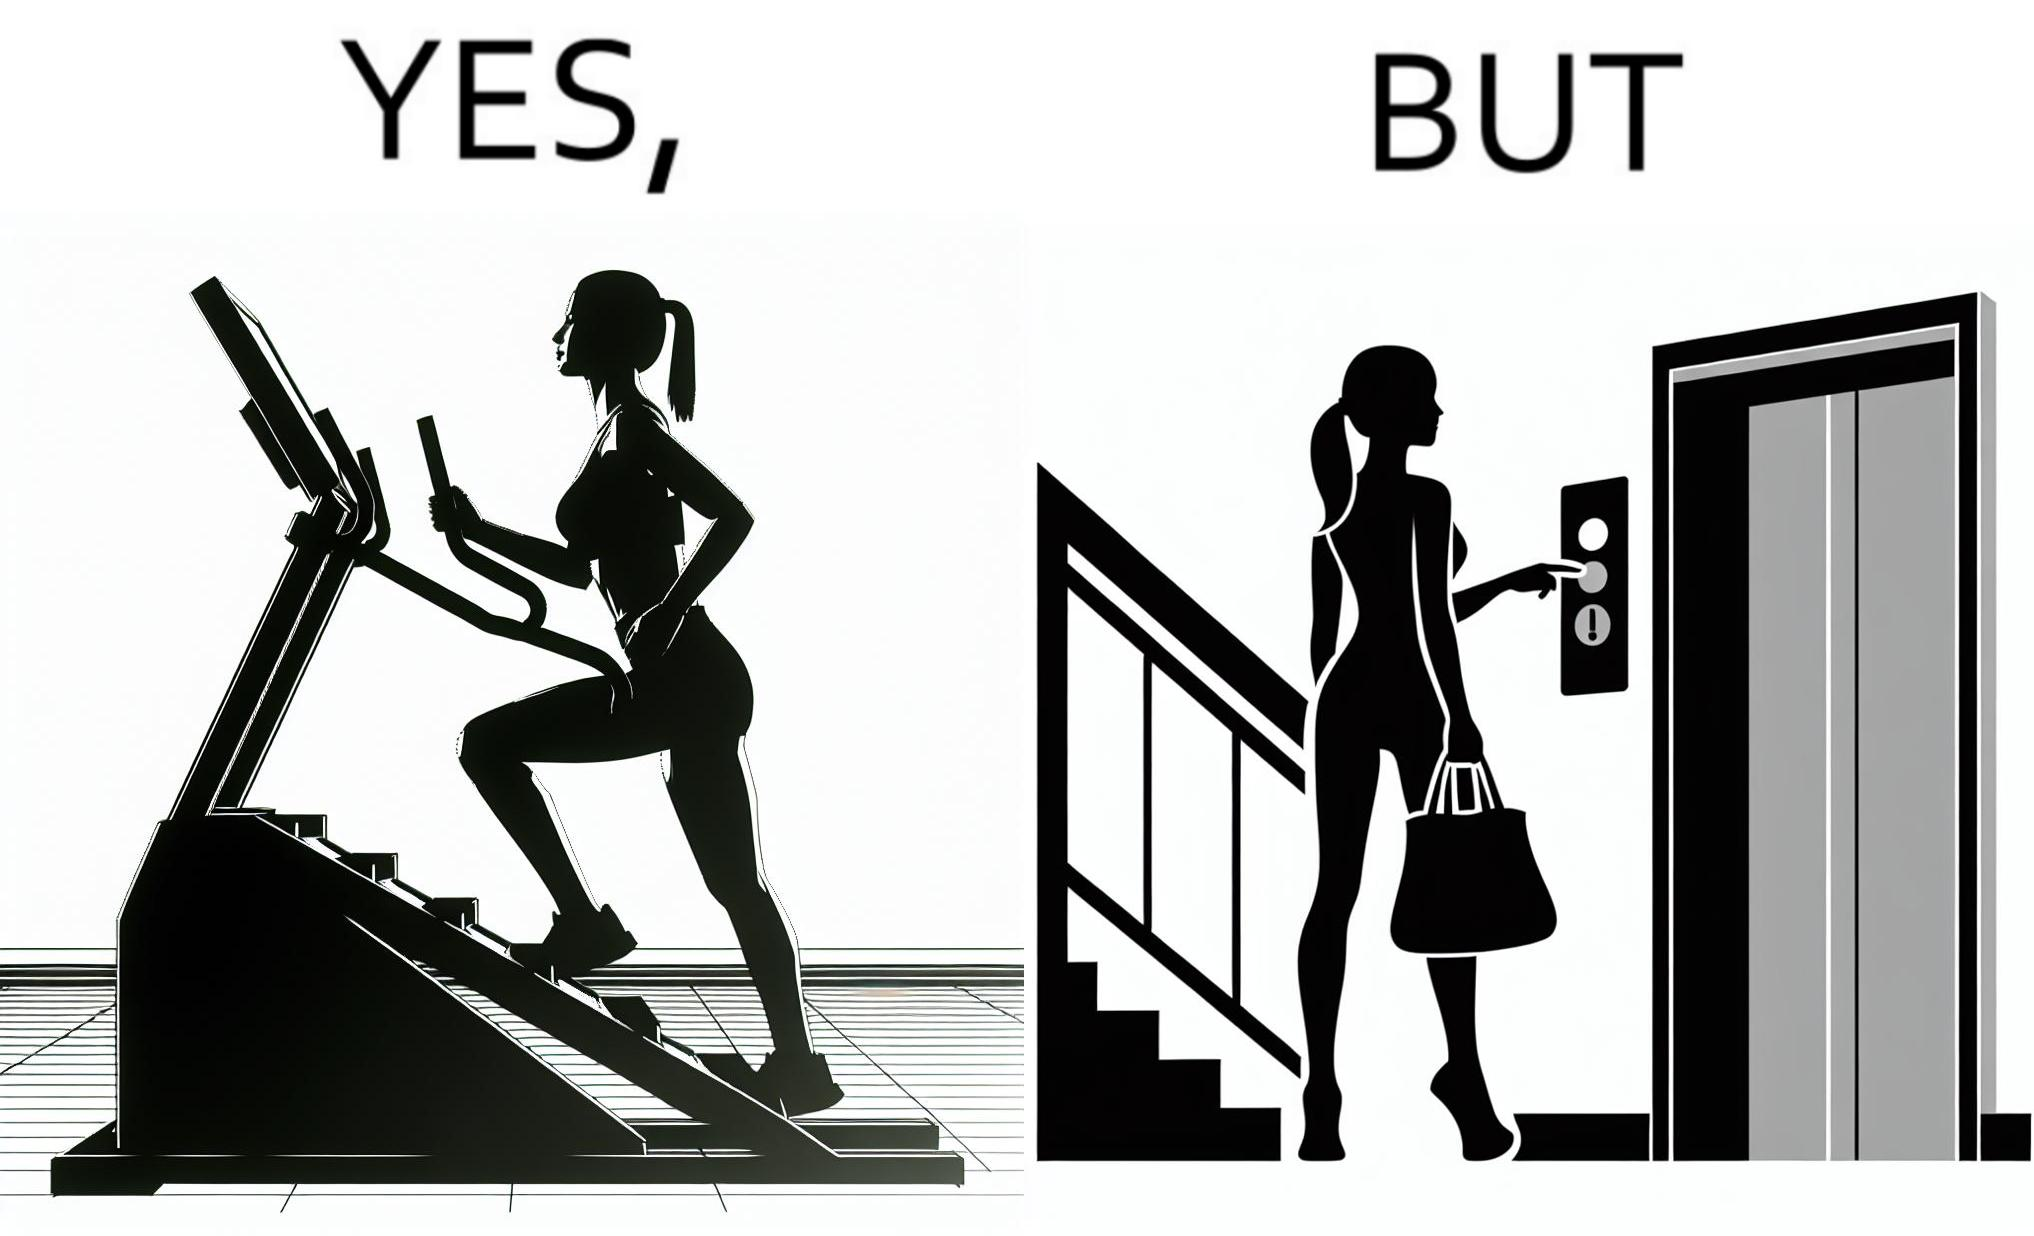Describe the content of this image. The image is ironic, because in the left image a woman is seen using the stair climber machine at the gym but the same woman is not ready to climb up some stairs for going to the gym and is calling for the lift 